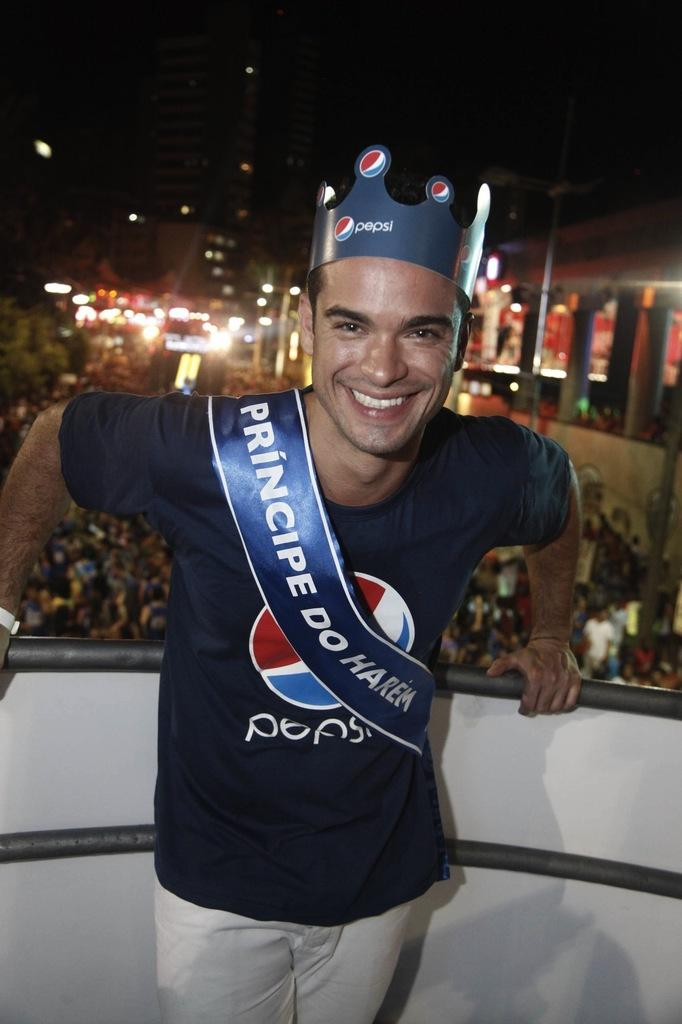<image>
Summarize the visual content of the image. A young man wearing a cardboard Pepsi crown, a Pepsi T-shirt and a banner in blue with white print saying PRINCIPE DO HAREM. 